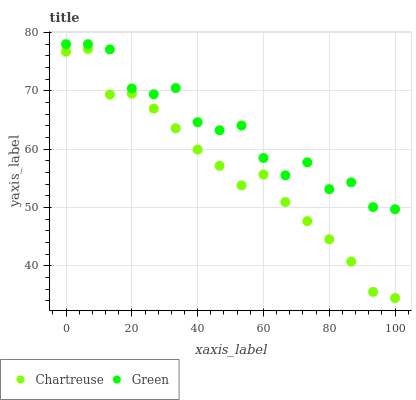Does Chartreuse have the minimum area under the curve?
Answer yes or no. Yes. Does Green have the maximum area under the curve?
Answer yes or no. Yes. Does Green have the minimum area under the curve?
Answer yes or no. No. Is Chartreuse the smoothest?
Answer yes or no. Yes. Is Green the roughest?
Answer yes or no. Yes. Is Green the smoothest?
Answer yes or no. No. Does Chartreuse have the lowest value?
Answer yes or no. Yes. Does Green have the lowest value?
Answer yes or no. No. Does Green have the highest value?
Answer yes or no. Yes. Is Chartreuse less than Green?
Answer yes or no. Yes. Is Green greater than Chartreuse?
Answer yes or no. Yes. Does Chartreuse intersect Green?
Answer yes or no. No. 